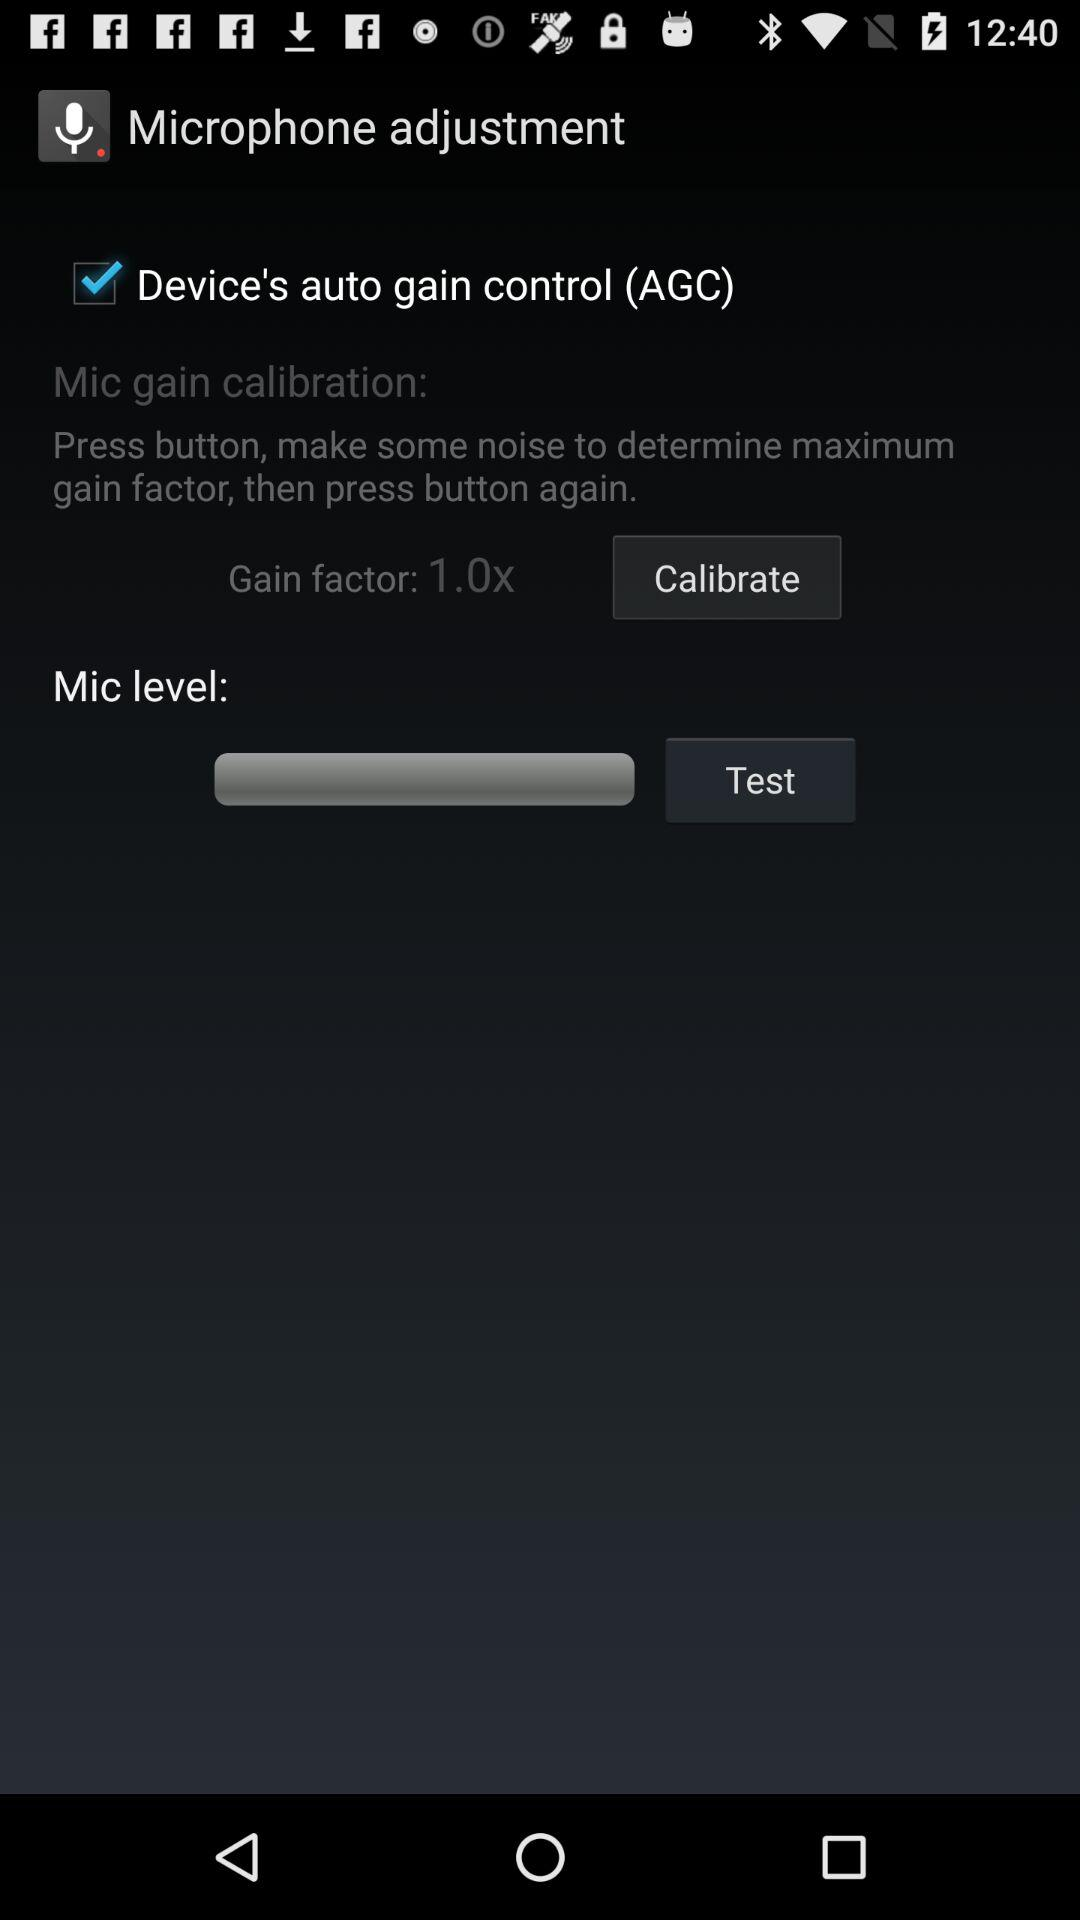What is the maximum level of gain factor that can be applied to the microphone?
Answer the question using a single word or phrase. 1.0x 